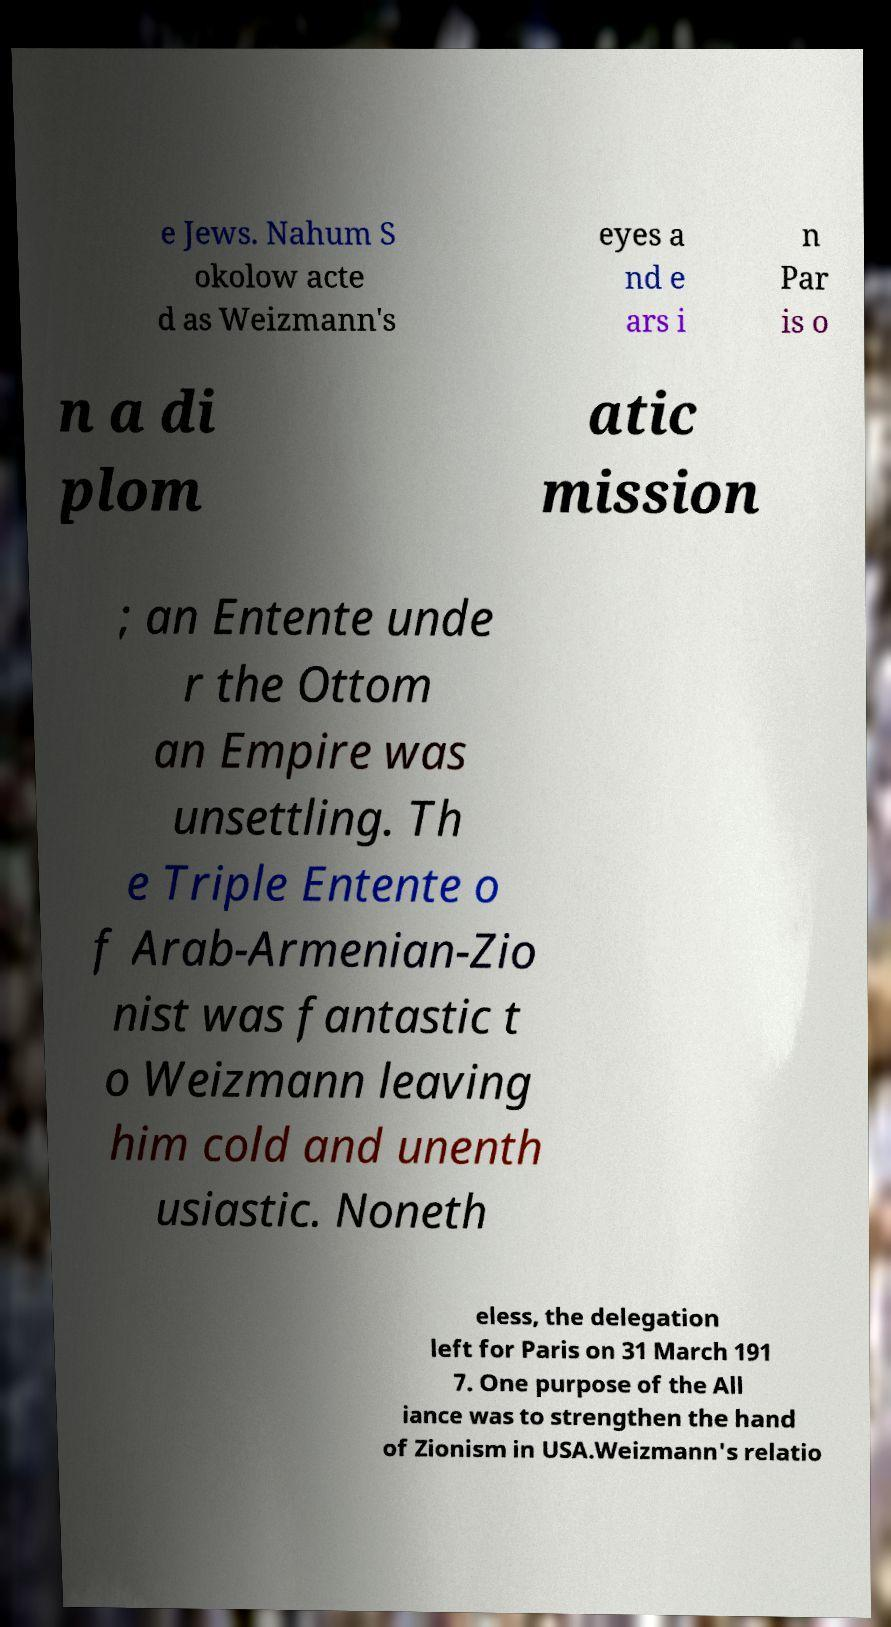Could you extract and type out the text from this image? e Jews. Nahum S okolow acte d as Weizmann's eyes a nd e ars i n Par is o n a di plom atic mission ; an Entente unde r the Ottom an Empire was unsettling. Th e Triple Entente o f Arab-Armenian-Zio nist was fantastic t o Weizmann leaving him cold and unenth usiastic. Noneth eless, the delegation left for Paris on 31 March 191 7. One purpose of the All iance was to strengthen the hand of Zionism in USA.Weizmann's relatio 